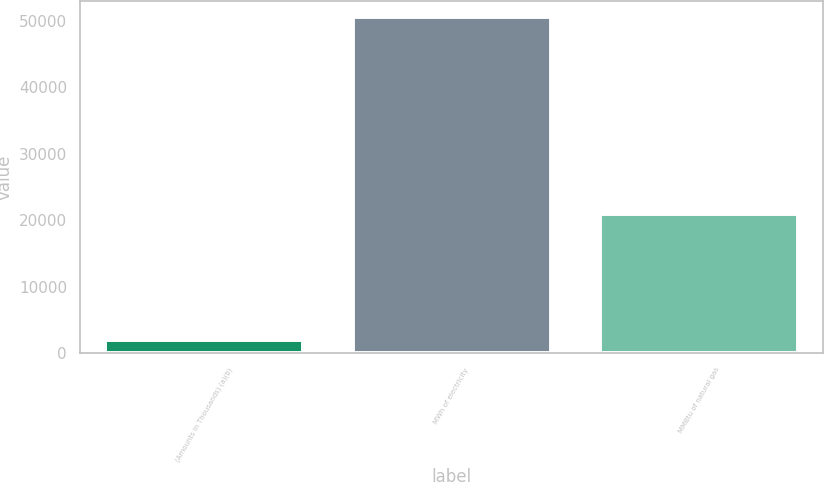Convert chart. <chart><loc_0><loc_0><loc_500><loc_500><bar_chart><fcel>(Amounts in Thousands) (a)(b)<fcel>MWh of electricity<fcel>MMBtu of natural gas<nl><fcel>2015<fcel>50487<fcel>20874<nl></chart> 